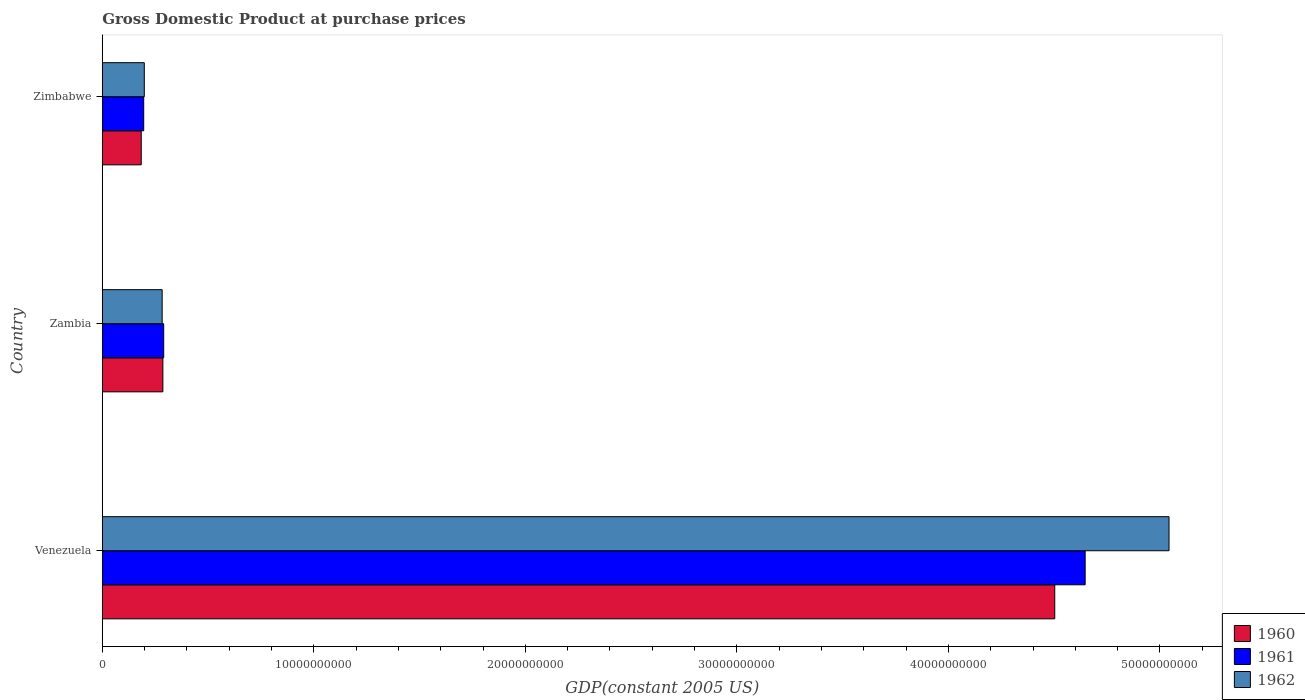Are the number of bars per tick equal to the number of legend labels?
Offer a very short reply. Yes. Are the number of bars on each tick of the Y-axis equal?
Keep it short and to the point. Yes. How many bars are there on the 1st tick from the top?
Your answer should be compact. 3. What is the label of the 2nd group of bars from the top?
Your response must be concise. Zambia. In how many cases, is the number of bars for a given country not equal to the number of legend labels?
Offer a very short reply. 0. What is the GDP at purchase prices in 1961 in Zimbabwe?
Ensure brevity in your answer.  1.96e+09. Across all countries, what is the maximum GDP at purchase prices in 1962?
Provide a succinct answer. 5.04e+1. Across all countries, what is the minimum GDP at purchase prices in 1962?
Offer a terse response. 1.99e+09. In which country was the GDP at purchase prices in 1962 maximum?
Keep it short and to the point. Venezuela. In which country was the GDP at purchase prices in 1960 minimum?
Your answer should be compact. Zimbabwe. What is the total GDP at purchase prices in 1961 in the graph?
Give a very brief answer. 5.13e+1. What is the difference between the GDP at purchase prices in 1960 in Venezuela and that in Zimbabwe?
Provide a succinct answer. 4.32e+1. What is the difference between the GDP at purchase prices in 1960 in Zimbabwe and the GDP at purchase prices in 1961 in Zambia?
Offer a very short reply. -1.06e+09. What is the average GDP at purchase prices in 1961 per country?
Provide a succinct answer. 1.71e+1. What is the difference between the GDP at purchase prices in 1961 and GDP at purchase prices in 1962 in Venezuela?
Ensure brevity in your answer.  -3.96e+09. In how many countries, is the GDP at purchase prices in 1961 greater than 40000000000 US$?
Keep it short and to the point. 1. What is the ratio of the GDP at purchase prices in 1962 in Venezuela to that in Zambia?
Your answer should be very brief. 17.8. Is the GDP at purchase prices in 1962 in Zambia less than that in Zimbabwe?
Your answer should be very brief. No. What is the difference between the highest and the second highest GDP at purchase prices in 1960?
Offer a terse response. 4.22e+1. What is the difference between the highest and the lowest GDP at purchase prices in 1961?
Offer a very short reply. 4.45e+1. In how many countries, is the GDP at purchase prices in 1962 greater than the average GDP at purchase prices in 1962 taken over all countries?
Provide a succinct answer. 1. Is it the case that in every country, the sum of the GDP at purchase prices in 1962 and GDP at purchase prices in 1960 is greater than the GDP at purchase prices in 1961?
Your answer should be very brief. Yes. How many bars are there?
Offer a terse response. 9. Are all the bars in the graph horizontal?
Provide a short and direct response. Yes. How many countries are there in the graph?
Your answer should be very brief. 3. Are the values on the major ticks of X-axis written in scientific E-notation?
Give a very brief answer. No. Does the graph contain grids?
Provide a short and direct response. No. Where does the legend appear in the graph?
Make the answer very short. Bottom right. How many legend labels are there?
Your answer should be compact. 3. How are the legend labels stacked?
Offer a terse response. Vertical. What is the title of the graph?
Provide a succinct answer. Gross Domestic Product at purchase prices. Does "1999" appear as one of the legend labels in the graph?
Your response must be concise. No. What is the label or title of the X-axis?
Make the answer very short. GDP(constant 2005 US). What is the GDP(constant 2005 US) of 1960 in Venezuela?
Give a very brief answer. 4.50e+1. What is the GDP(constant 2005 US) in 1961 in Venezuela?
Your answer should be compact. 4.65e+1. What is the GDP(constant 2005 US) in 1962 in Venezuela?
Ensure brevity in your answer.  5.04e+1. What is the GDP(constant 2005 US) in 1960 in Zambia?
Keep it short and to the point. 2.87e+09. What is the GDP(constant 2005 US) in 1961 in Zambia?
Keep it short and to the point. 2.91e+09. What is the GDP(constant 2005 US) in 1962 in Zambia?
Keep it short and to the point. 2.83e+09. What is the GDP(constant 2005 US) of 1960 in Zimbabwe?
Offer a very short reply. 1.84e+09. What is the GDP(constant 2005 US) of 1961 in Zimbabwe?
Your response must be concise. 1.96e+09. What is the GDP(constant 2005 US) in 1962 in Zimbabwe?
Offer a terse response. 1.99e+09. Across all countries, what is the maximum GDP(constant 2005 US) of 1960?
Keep it short and to the point. 4.50e+1. Across all countries, what is the maximum GDP(constant 2005 US) in 1961?
Offer a very short reply. 4.65e+1. Across all countries, what is the maximum GDP(constant 2005 US) in 1962?
Provide a succinct answer. 5.04e+1. Across all countries, what is the minimum GDP(constant 2005 US) in 1960?
Your answer should be very brief. 1.84e+09. Across all countries, what is the minimum GDP(constant 2005 US) of 1961?
Ensure brevity in your answer.  1.96e+09. Across all countries, what is the minimum GDP(constant 2005 US) in 1962?
Provide a short and direct response. 1.99e+09. What is the total GDP(constant 2005 US) of 1960 in the graph?
Your response must be concise. 4.97e+1. What is the total GDP(constant 2005 US) in 1961 in the graph?
Your answer should be compact. 5.13e+1. What is the total GDP(constant 2005 US) of 1962 in the graph?
Offer a terse response. 5.52e+1. What is the difference between the GDP(constant 2005 US) of 1960 in Venezuela and that in Zambia?
Provide a short and direct response. 4.22e+1. What is the difference between the GDP(constant 2005 US) of 1961 in Venezuela and that in Zambia?
Provide a succinct answer. 4.36e+1. What is the difference between the GDP(constant 2005 US) of 1962 in Venezuela and that in Zambia?
Offer a terse response. 4.76e+1. What is the difference between the GDP(constant 2005 US) in 1960 in Venezuela and that in Zimbabwe?
Your answer should be compact. 4.32e+1. What is the difference between the GDP(constant 2005 US) in 1961 in Venezuela and that in Zimbabwe?
Ensure brevity in your answer.  4.45e+1. What is the difference between the GDP(constant 2005 US) in 1962 in Venezuela and that in Zimbabwe?
Your answer should be very brief. 4.84e+1. What is the difference between the GDP(constant 2005 US) of 1960 in Zambia and that in Zimbabwe?
Your answer should be compact. 1.02e+09. What is the difference between the GDP(constant 2005 US) of 1961 in Zambia and that in Zimbabwe?
Your answer should be very brief. 9.46e+08. What is the difference between the GDP(constant 2005 US) of 1962 in Zambia and that in Zimbabwe?
Your response must be concise. 8.45e+08. What is the difference between the GDP(constant 2005 US) of 1960 in Venezuela and the GDP(constant 2005 US) of 1961 in Zambia?
Your answer should be compact. 4.21e+1. What is the difference between the GDP(constant 2005 US) of 1960 in Venezuela and the GDP(constant 2005 US) of 1962 in Zambia?
Your answer should be compact. 4.22e+1. What is the difference between the GDP(constant 2005 US) in 1961 in Venezuela and the GDP(constant 2005 US) in 1962 in Zambia?
Your answer should be compact. 4.36e+1. What is the difference between the GDP(constant 2005 US) of 1960 in Venezuela and the GDP(constant 2005 US) of 1961 in Zimbabwe?
Ensure brevity in your answer.  4.31e+1. What is the difference between the GDP(constant 2005 US) in 1960 in Venezuela and the GDP(constant 2005 US) in 1962 in Zimbabwe?
Keep it short and to the point. 4.30e+1. What is the difference between the GDP(constant 2005 US) of 1961 in Venezuela and the GDP(constant 2005 US) of 1962 in Zimbabwe?
Provide a succinct answer. 4.45e+1. What is the difference between the GDP(constant 2005 US) in 1960 in Zambia and the GDP(constant 2005 US) in 1961 in Zimbabwe?
Provide a succinct answer. 9.07e+08. What is the difference between the GDP(constant 2005 US) of 1960 in Zambia and the GDP(constant 2005 US) of 1962 in Zimbabwe?
Keep it short and to the point. 8.79e+08. What is the difference between the GDP(constant 2005 US) in 1961 in Zambia and the GDP(constant 2005 US) in 1962 in Zimbabwe?
Give a very brief answer. 9.18e+08. What is the average GDP(constant 2005 US) in 1960 per country?
Offer a terse response. 1.66e+1. What is the average GDP(constant 2005 US) in 1961 per country?
Offer a terse response. 1.71e+1. What is the average GDP(constant 2005 US) in 1962 per country?
Keep it short and to the point. 1.84e+1. What is the difference between the GDP(constant 2005 US) of 1960 and GDP(constant 2005 US) of 1961 in Venezuela?
Give a very brief answer. -1.44e+09. What is the difference between the GDP(constant 2005 US) in 1960 and GDP(constant 2005 US) in 1962 in Venezuela?
Offer a very short reply. -5.40e+09. What is the difference between the GDP(constant 2005 US) in 1961 and GDP(constant 2005 US) in 1962 in Venezuela?
Your response must be concise. -3.96e+09. What is the difference between the GDP(constant 2005 US) of 1960 and GDP(constant 2005 US) of 1961 in Zambia?
Your response must be concise. -3.90e+07. What is the difference between the GDP(constant 2005 US) in 1960 and GDP(constant 2005 US) in 1962 in Zambia?
Offer a very short reply. 3.33e+07. What is the difference between the GDP(constant 2005 US) of 1961 and GDP(constant 2005 US) of 1962 in Zambia?
Your answer should be very brief. 7.24e+07. What is the difference between the GDP(constant 2005 US) of 1960 and GDP(constant 2005 US) of 1961 in Zimbabwe?
Keep it short and to the point. -1.16e+08. What is the difference between the GDP(constant 2005 US) in 1960 and GDP(constant 2005 US) in 1962 in Zimbabwe?
Keep it short and to the point. -1.45e+08. What is the difference between the GDP(constant 2005 US) in 1961 and GDP(constant 2005 US) in 1962 in Zimbabwe?
Offer a very short reply. -2.81e+07. What is the ratio of the GDP(constant 2005 US) in 1960 in Venezuela to that in Zambia?
Make the answer very short. 15.71. What is the ratio of the GDP(constant 2005 US) of 1961 in Venezuela to that in Zambia?
Keep it short and to the point. 15.99. What is the ratio of the GDP(constant 2005 US) in 1962 in Venezuela to that in Zambia?
Provide a succinct answer. 17.8. What is the ratio of the GDP(constant 2005 US) in 1960 in Venezuela to that in Zimbabwe?
Ensure brevity in your answer.  24.43. What is the ratio of the GDP(constant 2005 US) of 1961 in Venezuela to that in Zimbabwe?
Give a very brief answer. 23.71. What is the ratio of the GDP(constant 2005 US) of 1962 in Venezuela to that in Zimbabwe?
Give a very brief answer. 25.37. What is the ratio of the GDP(constant 2005 US) in 1960 in Zambia to that in Zimbabwe?
Keep it short and to the point. 1.56. What is the ratio of the GDP(constant 2005 US) in 1961 in Zambia to that in Zimbabwe?
Your answer should be very brief. 1.48. What is the ratio of the GDP(constant 2005 US) in 1962 in Zambia to that in Zimbabwe?
Your response must be concise. 1.43. What is the difference between the highest and the second highest GDP(constant 2005 US) in 1960?
Offer a very short reply. 4.22e+1. What is the difference between the highest and the second highest GDP(constant 2005 US) of 1961?
Give a very brief answer. 4.36e+1. What is the difference between the highest and the second highest GDP(constant 2005 US) of 1962?
Your answer should be compact. 4.76e+1. What is the difference between the highest and the lowest GDP(constant 2005 US) of 1960?
Keep it short and to the point. 4.32e+1. What is the difference between the highest and the lowest GDP(constant 2005 US) in 1961?
Ensure brevity in your answer.  4.45e+1. What is the difference between the highest and the lowest GDP(constant 2005 US) in 1962?
Give a very brief answer. 4.84e+1. 